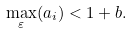<formula> <loc_0><loc_0><loc_500><loc_500>\max _ { \varepsilon } ( a _ { i } ) < 1 + b .</formula> 